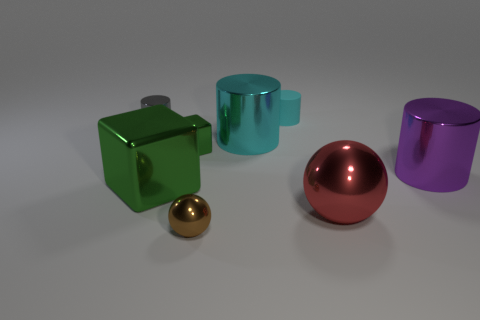Subtract all matte cylinders. How many cylinders are left? 3 Subtract all purple cylinders. How many cylinders are left? 3 Subtract 2 cylinders. How many cylinders are left? 2 Subtract all purple blocks. How many red spheres are left? 1 Add 1 small purple cylinders. How many objects exist? 9 Subtract all green cylinders. Subtract all yellow blocks. How many cylinders are left? 4 Subtract all big objects. Subtract all gray shiny objects. How many objects are left? 3 Add 3 small metallic spheres. How many small metallic spheres are left? 4 Add 6 small gray metal cylinders. How many small gray metal cylinders exist? 7 Subtract 1 brown balls. How many objects are left? 7 